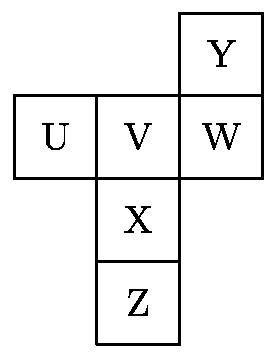A piece of paper containing six joined squares labeled as shown in the diagram is folded along the edges of the squares to form a cube.  The label of the face opposite the face labeled $ \text{X}$ is: Choices: ['$\\text{Z}$', '$\\text{U}$', '$\\text{V}$', '$\\text{W}$', '$\\text{Y}$'] To determine the face opposite 'X', envision how the paper folds into a cube. 'Z' is directly below 'X', making it the opposite face when folded. Thus, the label of the face opposite the face labeled '$ \text{X}$' is '$ \text{Z}$'. 